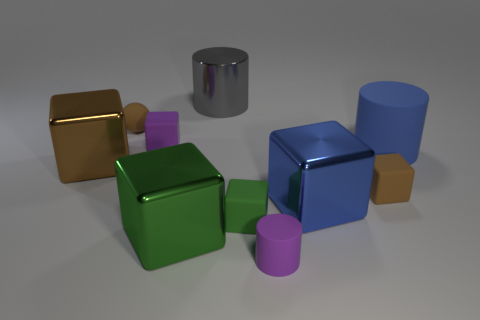Subtract all small purple cylinders. How many cylinders are left? 2 Subtract all blue cylinders. How many cylinders are left? 2 Subtract 4 cubes. How many cubes are left? 2 Subtract all red cylinders. Subtract all yellow balls. How many cylinders are left? 3 Add 3 green things. How many green things are left? 5 Add 3 large metallic cylinders. How many large metallic cylinders exist? 4 Subtract 0 cyan cylinders. How many objects are left? 10 Subtract all cylinders. How many objects are left? 7 Subtract all green cylinders. How many brown blocks are left? 2 Subtract all large metal things. Subtract all tiny green metallic blocks. How many objects are left? 6 